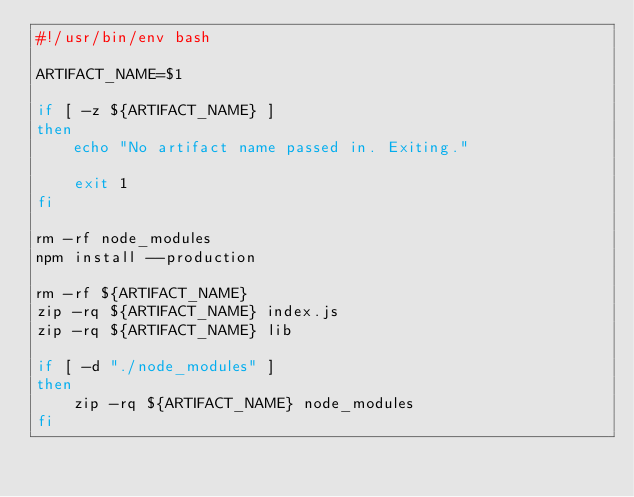Convert code to text. <code><loc_0><loc_0><loc_500><loc_500><_Bash_>#!/usr/bin/env bash

ARTIFACT_NAME=$1

if [ -z ${ARTIFACT_NAME} ]
then
    echo "No artifact name passed in. Exiting."

    exit 1
fi

rm -rf node_modules
npm install --production

rm -rf ${ARTIFACT_NAME}
zip -rq ${ARTIFACT_NAME} index.js
zip -rq ${ARTIFACT_NAME} lib      

if [ -d "./node_modules" ] 
then
    zip -rq ${ARTIFACT_NAME} node_modules
fi
</code> 